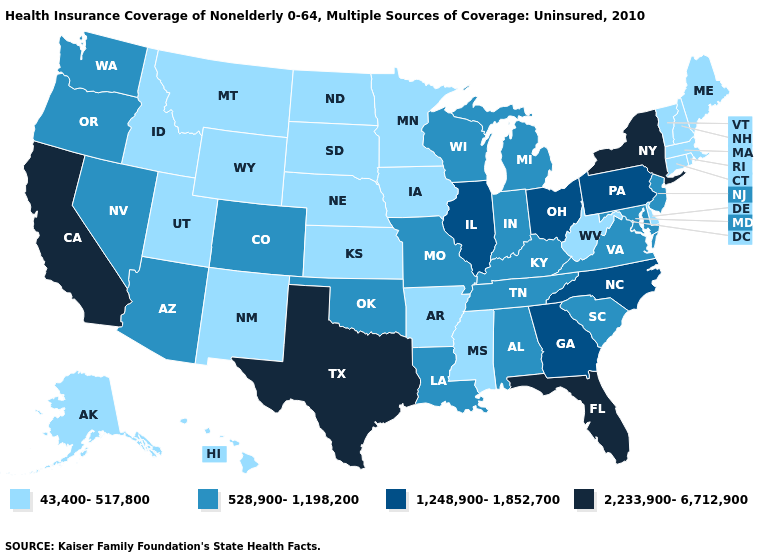Among the states that border Tennessee , which have the lowest value?
Short answer required. Arkansas, Mississippi. What is the lowest value in states that border Michigan?
Concise answer only. 528,900-1,198,200. Does Mississippi have the same value as New York?
Answer briefly. No. Name the states that have a value in the range 1,248,900-1,852,700?
Answer briefly. Georgia, Illinois, North Carolina, Ohio, Pennsylvania. Among the states that border Wyoming , which have the lowest value?
Answer briefly. Idaho, Montana, Nebraska, South Dakota, Utah. What is the value of Alabama?
Short answer required. 528,900-1,198,200. Among the states that border Louisiana , which have the highest value?
Be succinct. Texas. Name the states that have a value in the range 1,248,900-1,852,700?
Give a very brief answer. Georgia, Illinois, North Carolina, Ohio, Pennsylvania. Name the states that have a value in the range 2,233,900-6,712,900?
Short answer required. California, Florida, New York, Texas. Does the map have missing data?
Short answer required. No. What is the value of Florida?
Answer briefly. 2,233,900-6,712,900. What is the value of Texas?
Be succinct. 2,233,900-6,712,900. How many symbols are there in the legend?
Write a very short answer. 4. Among the states that border Iowa , which have the lowest value?
Concise answer only. Minnesota, Nebraska, South Dakota. Name the states that have a value in the range 1,248,900-1,852,700?
Give a very brief answer. Georgia, Illinois, North Carolina, Ohio, Pennsylvania. 